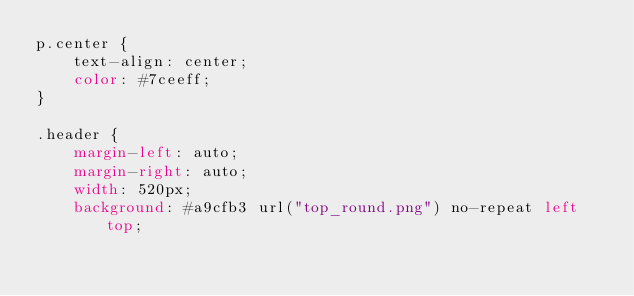<code> <loc_0><loc_0><loc_500><loc_500><_CSS_>p.center {
	text-align: center;
	color: #7ceeff;
}

.header {
	margin-left: auto;
	margin-right: auto;
	width: 520px;
	background: #a9cfb3 url("top_round.png") no-repeat left top;</code> 